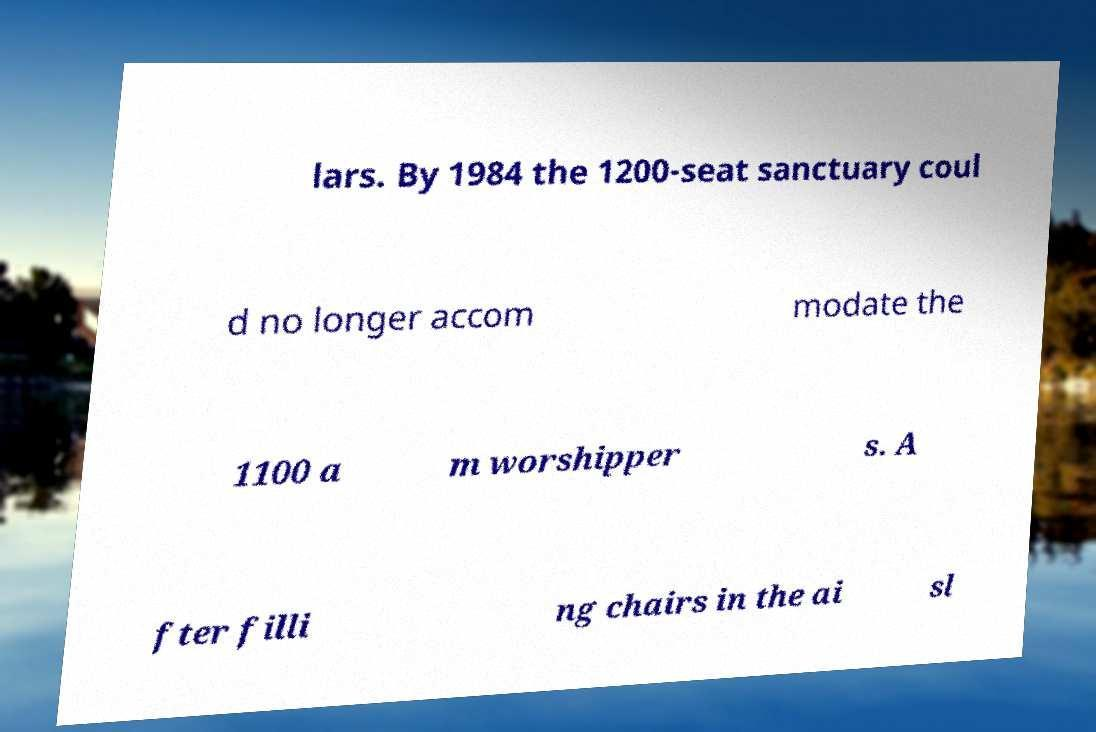For documentation purposes, I need the text within this image transcribed. Could you provide that? lars. By 1984 the 1200-seat sanctuary coul d no longer accom modate the 1100 a m worshipper s. A fter filli ng chairs in the ai sl 